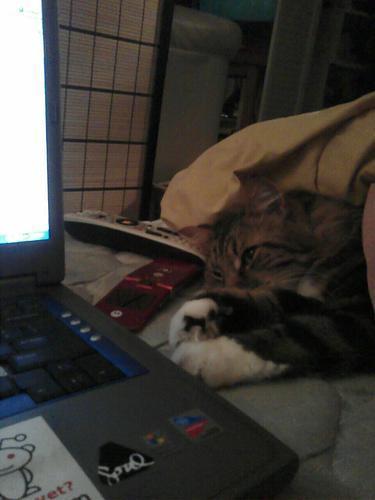How many cats?
Give a very brief answer. 1. How many remotes are in the picture?
Give a very brief answer. 2. How many giraffes do you see?
Give a very brief answer. 0. 